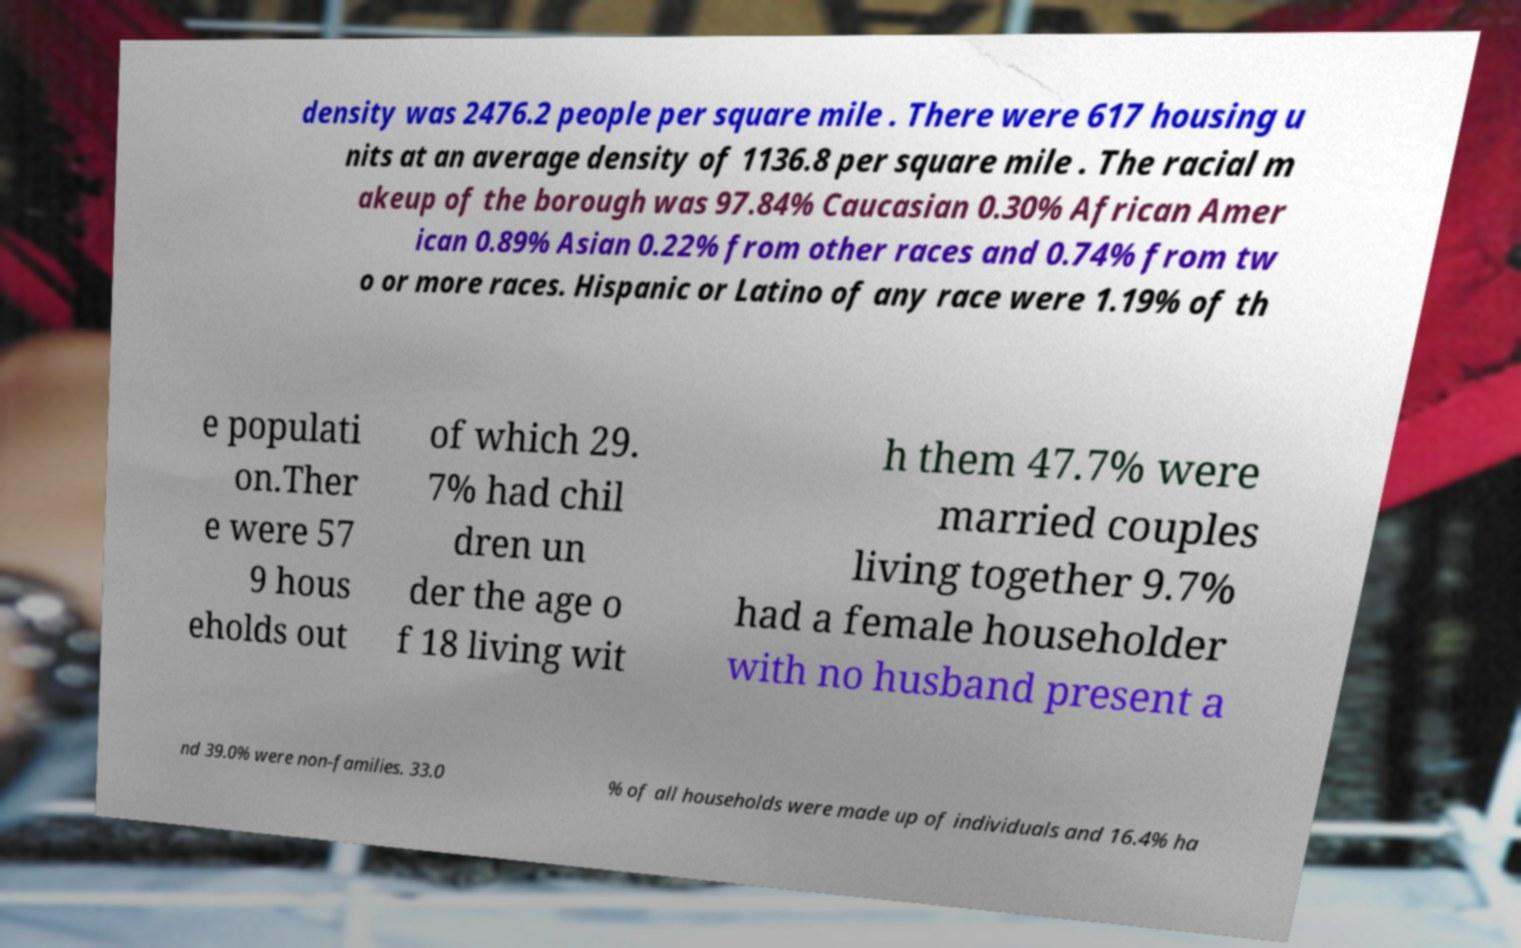For documentation purposes, I need the text within this image transcribed. Could you provide that? density was 2476.2 people per square mile . There were 617 housing u nits at an average density of 1136.8 per square mile . The racial m akeup of the borough was 97.84% Caucasian 0.30% African Amer ican 0.89% Asian 0.22% from other races and 0.74% from tw o or more races. Hispanic or Latino of any race were 1.19% of th e populati on.Ther e were 57 9 hous eholds out of which 29. 7% had chil dren un der the age o f 18 living wit h them 47.7% were married couples living together 9.7% had a female householder with no husband present a nd 39.0% were non-families. 33.0 % of all households were made up of individuals and 16.4% ha 